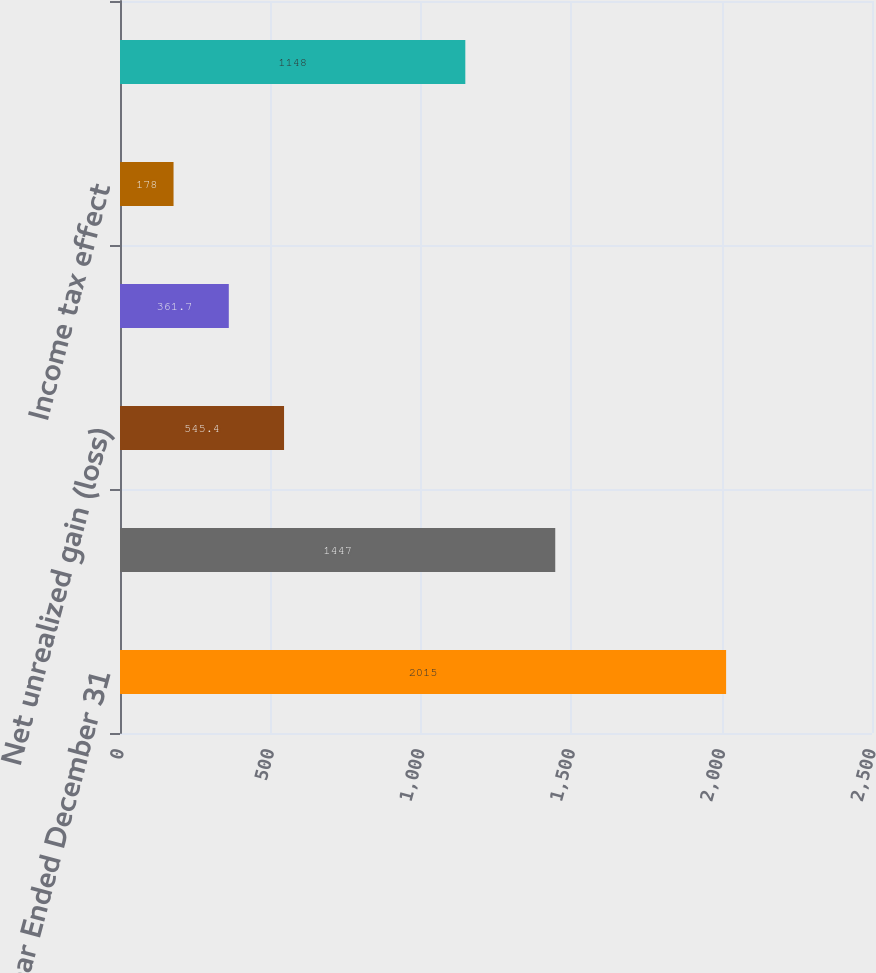Convert chart to OTSL. <chart><loc_0><loc_0><loc_500><loc_500><bar_chart><fcel>Year Ended December 31<fcel>Net income<fcel>Net unrealized gain (loss)<fcel>Other comprehensive income<fcel>Income tax effect<fcel>Comprehensive Income<nl><fcel>2015<fcel>1447<fcel>545.4<fcel>361.7<fcel>178<fcel>1148<nl></chart> 